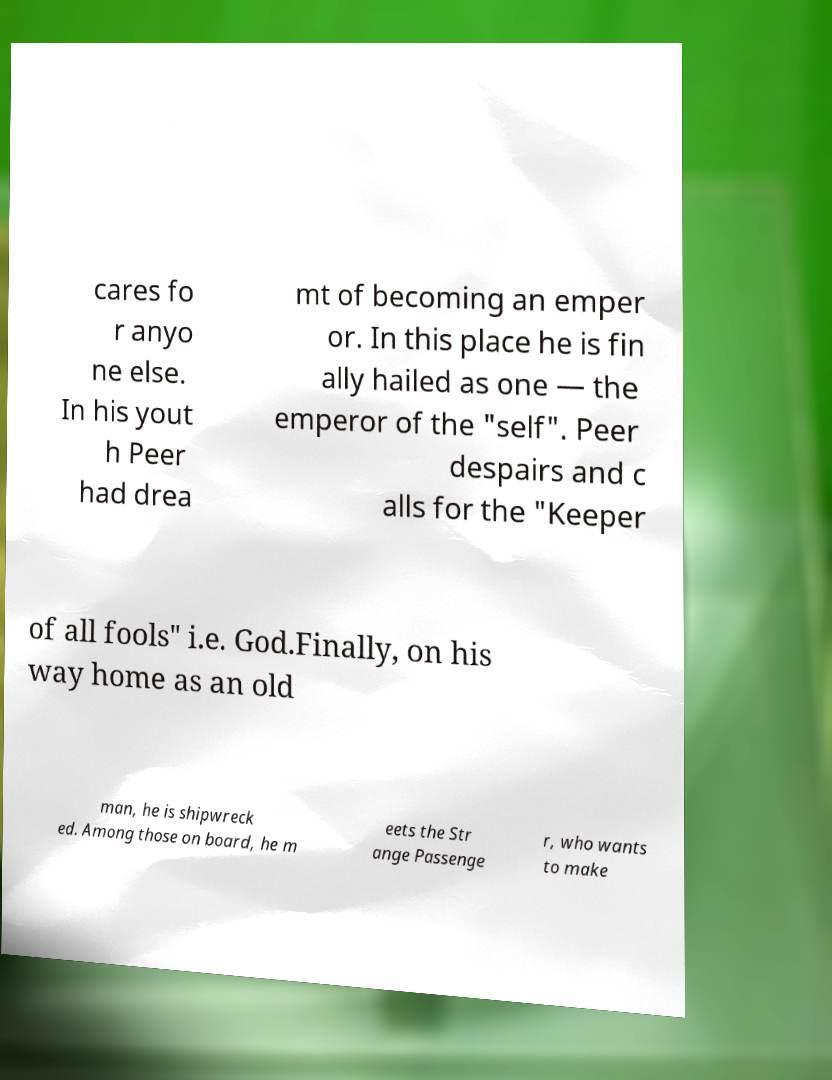Please read and relay the text visible in this image. What does it say? cares fo r anyo ne else. In his yout h Peer had drea mt of becoming an emper or. In this place he is fin ally hailed as one — the emperor of the "self". Peer despairs and c alls for the "Keeper of all fools" i.e. God.Finally, on his way home as an old man, he is shipwreck ed. Among those on board, he m eets the Str ange Passenge r, who wants to make 